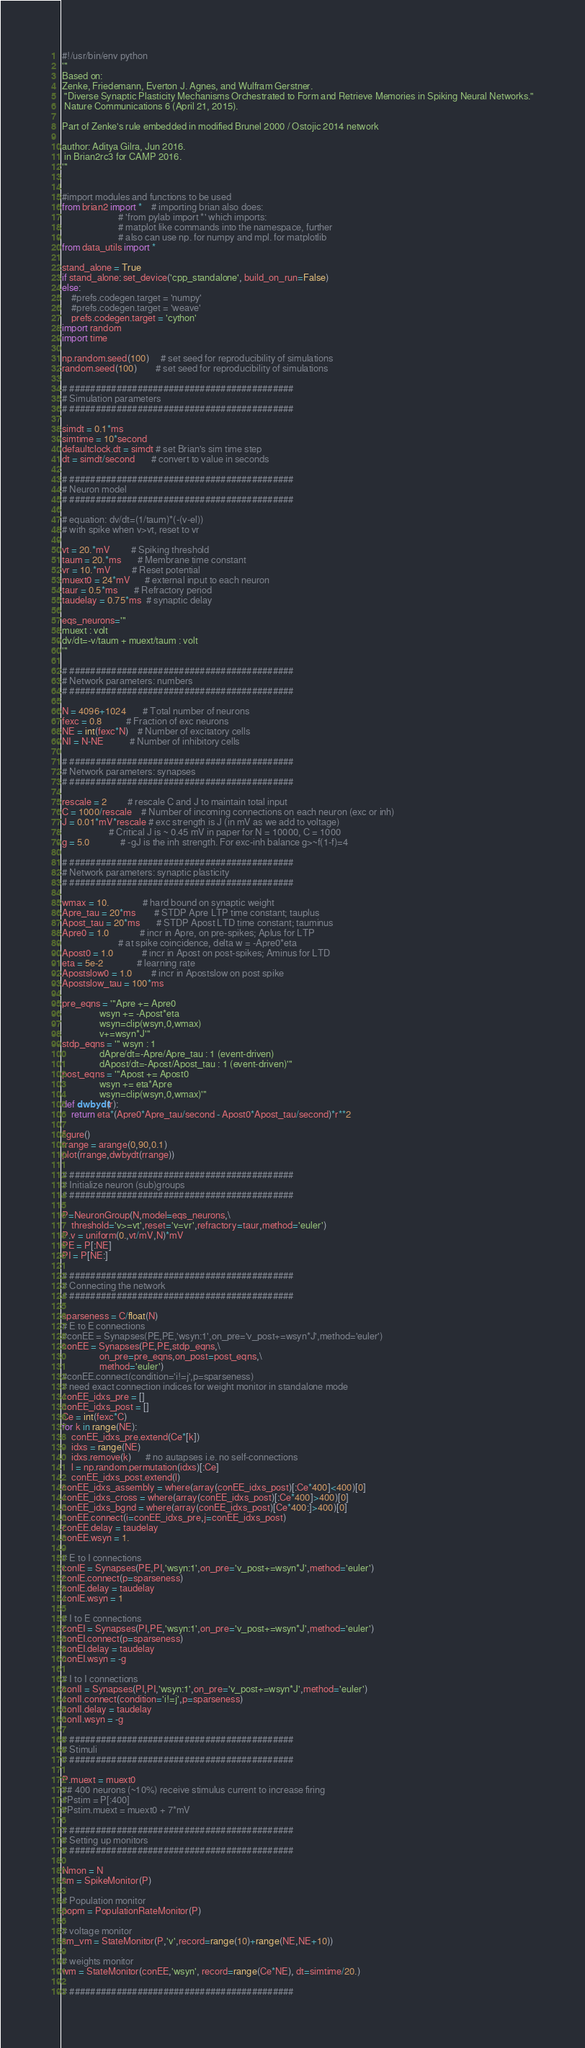<code> <loc_0><loc_0><loc_500><loc_500><_Python_>#!/usr/bin/env python
'''
Based on:
Zenke, Friedemann, Everton J. Agnes, and Wulfram Gerstner.
 "Diverse Synaptic Plasticity Mechanisms Orchestrated to Form and Retrieve Memories in Spiking Neural Networks."
 Nature Communications 6 (April 21, 2015).

Part of Zenke's rule embedded in modified Brunel 2000 / Ostojic 2014 network

author: Aditya Gilra, Jun 2016.
 in Brian2rc3 for CAMP 2016.
'''


#import modules and functions to be used
from brian2 import *    # importing brian also does:
                        # 'from pylab import *' which imports:
                        # matplot like commands into the namespace, further
                        # also can use np. for numpy and mpl. for matplotlib
from data_utils import *

stand_alone = True
if stand_alone: set_device('cpp_standalone', build_on_run=False)
else:
    #prefs.codegen.target = 'numpy'
    #prefs.codegen.target = 'weave'
    prefs.codegen.target = 'cython'
import random
import time

np.random.seed(100)     # set seed for reproducibility of simulations
random.seed(100)        # set seed for reproducibility of simulations

# ###########################################
# Simulation parameters
# ###########################################

simdt = 0.1*ms
simtime = 10*second
defaultclock.dt = simdt # set Brian's sim time step
dt = simdt/second       # convert to value in seconds

# ###########################################
# Neuron model
# ###########################################

# equation: dv/dt=(1/taum)*(-(v-el))
# with spike when v>vt, reset to vr

vt = 20.*mV         # Spiking threshold
taum = 20.*ms       # Membrane time constant
vr = 10.*mV         # Reset potential
muext0 = 24*mV      # external input to each neuron
taur = 0.5*ms       # Refractory period
taudelay = 0.75*ms  # synaptic delay

eqs_neurons='''
muext : volt
dv/dt=-v/taum + muext/taum : volt
'''

# ###########################################
# Network parameters: numbers
# ###########################################

N = 4096+1024       # Total number of neurons
fexc = 0.8          # Fraction of exc neurons
NE = int(fexc*N)    # Number of excitatory cells
NI = N-NE           # Number of inhibitory cells 

# ###########################################
# Network parameters: synapses
# ###########################################

rescale = 2         # rescale C and J to maintain total input
C = 1000/rescale    # Number of incoming connections on each neuron (exc or inh)
J = 0.01*mV*rescale # exc strength is J (in mV as we add to voltage)
                    # Critical J is ~ 0.45 mV in paper for N = 10000, C = 1000
g = 5.0             # -gJ is the inh strength. For exc-inh balance g>~f(1-f)=4

# ###########################################
# Network parameters: synaptic plasticity
# ###########################################

wmax = 10.              # hard bound on synaptic weight
Apre_tau = 20*ms        # STDP Apre LTP time constant; tauplus
Apost_tau = 20*ms       # STDP Apost LTD time constant; tauminus
Apre0 = 1.0             # incr in Apre, on pre-spikes; Aplus for LTP
                        # at spike coincidence, delta w = -Apre0*eta
Apost0 = 1.0            # incr in Apost on post-spikes; Aminus for LTD
eta = 5e-2              # learning rate
Apostslow0 = 1.0        # incr in Apostslow on post spike
Apostslow_tau = 100*ms

pre_eqns = '''Apre += Apre0
                wsyn += -Apost*eta
                wsyn=clip(wsyn,0,wmax)
                v+=wsyn*J'''
stdp_eqns = ''' wsyn : 1
                dApre/dt=-Apre/Apre_tau : 1 (event-driven)
                dApost/dt=-Apost/Apost_tau : 1 (event-driven)'''
post_eqns = '''Apost += Apost0
                wsyn += eta*Apre
                wsyn=clip(wsyn,0,wmax)'''
def dwbydt(r):
    return eta*(Apre0*Apre_tau/second - Apost0*Apost_tau/second)*r**2

figure()
rrange = arange(0,90,0.1)
plot(rrange,dwbydt(rrange))

# ###########################################
# Initialize neuron (sub)groups
# ###########################################

P=NeuronGroup(N,model=eqs_neurons,\
    threshold='v>=vt',reset='v=vr',refractory=taur,method='euler')
P.v = uniform(0.,vt/mV,N)*mV
PE = P[:NE]
PI = P[NE:]

# ###########################################
# Connecting the network 
# ###########################################

sparseness = C/float(N)
# E to E connections
#conEE = Synapses(PE,PE,'wsyn:1',on_pre='v_post+=wsyn*J',method='euler')
conEE = Synapses(PE,PE,stdp_eqns,\
                on_pre=pre_eqns,on_post=post_eqns,\
                method='euler')
#conEE.connect(condition='i!=j',p=sparseness)
# need exact connection indices for weight monitor in standalone mode
conEE_idxs_pre = []
conEE_idxs_post = []
Ce = int(fexc*C)
for k in range(NE):
    conEE_idxs_pre.extend(Ce*[k])
    idxs = range(NE)
    idxs.remove(k)      # no autapses i.e. no self-connections
    l = np.random.permutation(idxs)[:Ce]
    conEE_idxs_post.extend(l)
conEE_idxs_assembly = where(array(conEE_idxs_post)[:Ce*400]<400)[0]
conEE_idxs_cross = where(array(conEE_idxs_post)[:Ce*400]>400)[0]
conEE_idxs_bgnd = where(array(conEE_idxs_post)[Ce*400:]>400)[0]
conEE.connect(i=conEE_idxs_pre,j=conEE_idxs_post)
conEE.delay = taudelay
conEE.wsyn = 1.

# E to I connections
conIE = Synapses(PE,PI,'wsyn:1',on_pre='v_post+=wsyn*J',method='euler')
conIE.connect(p=sparseness)
conIE.delay = taudelay
conIE.wsyn = 1

# I to E connections
conEI = Synapses(PI,PE,'wsyn:1',on_pre='v_post+=wsyn*J',method='euler')
conEI.connect(p=sparseness)
conEI.delay = taudelay
conEI.wsyn = -g

# I to I connections
conII = Synapses(PI,PI,'wsyn:1',on_pre='v_post+=wsyn*J',method='euler')
conII.connect(condition='i!=j',p=sparseness)
conII.delay = taudelay
conII.wsyn = -g

# ###########################################
# Stimuli
# ###########################################

P.muext = muext0
## 400 neurons (~10%) receive stimulus current to increase firing
#Pstim = P[:400]
#Pstim.muext = muext0 + 7*mV

# ###########################################
# Setting up monitors
# ###########################################

Nmon = N
sm = SpikeMonitor(P)

# Population monitor
popm = PopulationRateMonitor(P)

# voltage monitor
sm_vm = StateMonitor(P,'v',record=range(10)+range(NE,NE+10))

# weights monitor
wm = StateMonitor(conEE,'wsyn', record=range(Ce*NE), dt=simtime/20.)

# ###########################################</code> 